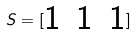<formula> <loc_0><loc_0><loc_500><loc_500>S = [ \begin{matrix} 1 & 1 & 1 \end{matrix} ]</formula> 